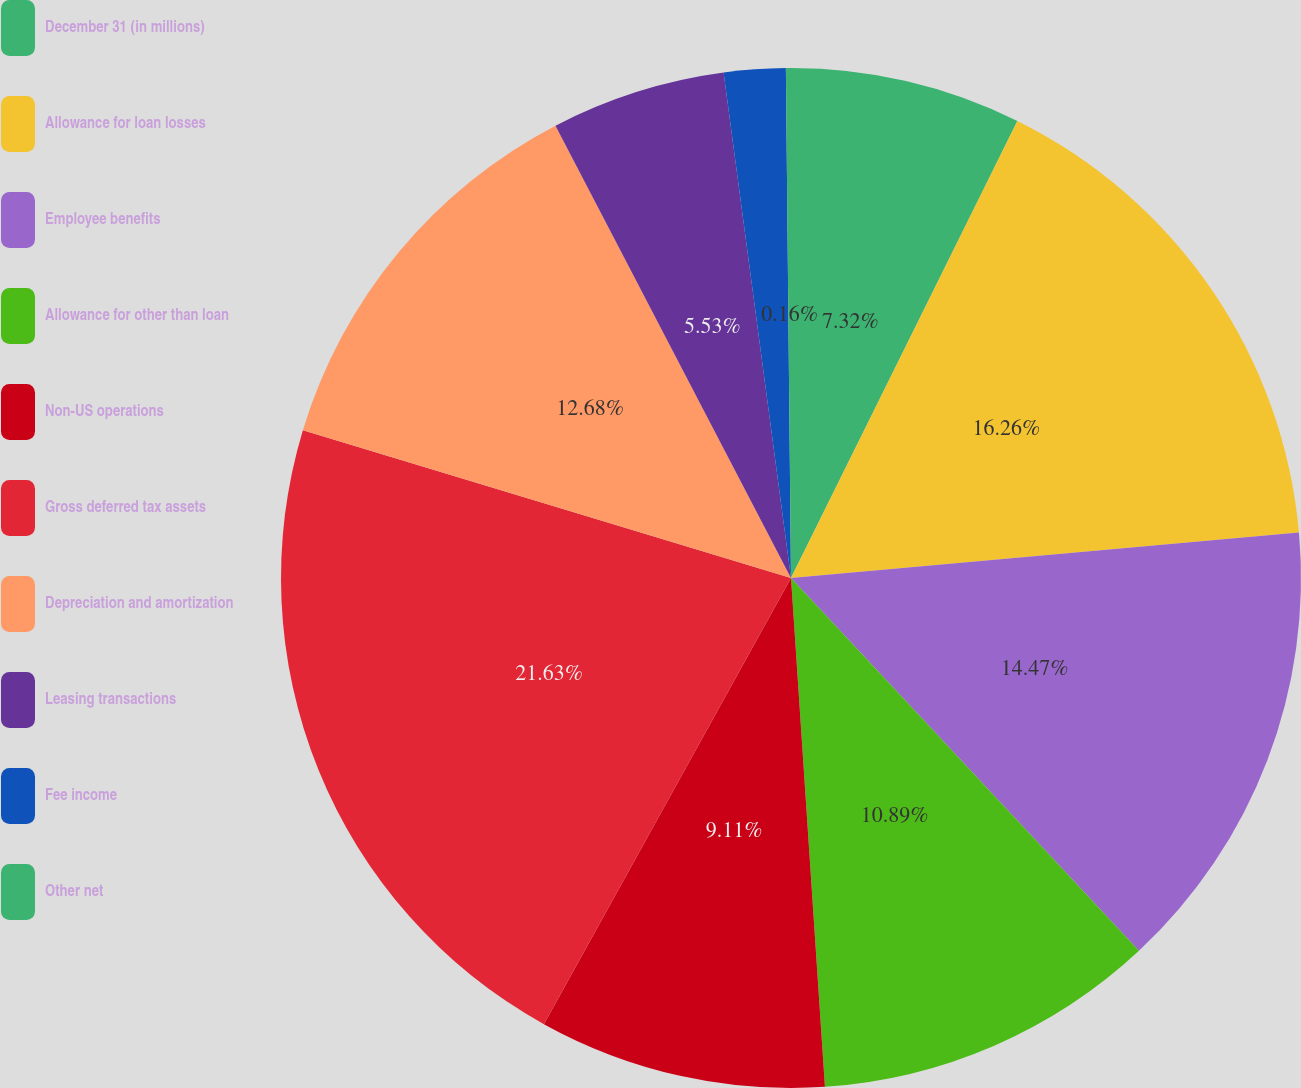Convert chart to OTSL. <chart><loc_0><loc_0><loc_500><loc_500><pie_chart><fcel>December 31 (in millions)<fcel>Allowance for loan losses<fcel>Employee benefits<fcel>Allowance for other than loan<fcel>Non-US operations<fcel>Gross deferred tax assets<fcel>Depreciation and amortization<fcel>Leasing transactions<fcel>Fee income<fcel>Other net<nl><fcel>7.32%<fcel>16.26%<fcel>14.47%<fcel>10.89%<fcel>9.11%<fcel>21.63%<fcel>12.68%<fcel>5.53%<fcel>1.95%<fcel>0.16%<nl></chart> 